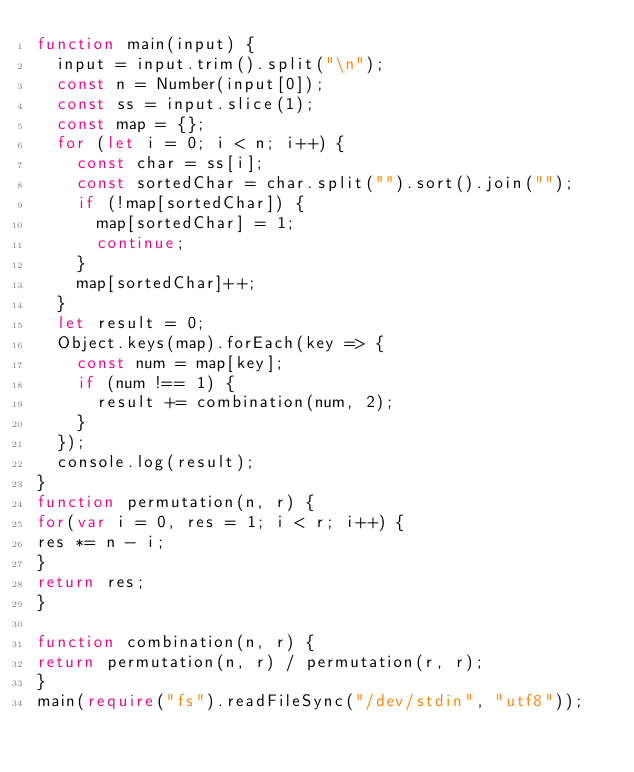<code> <loc_0><loc_0><loc_500><loc_500><_TypeScript_>function main(input) {
  input = input.trim().split("\n");
  const n = Number(input[0]);
  const ss = input.slice(1);
  const map = {};
  for (let i = 0; i < n; i++) {
    const char = ss[i];
    const sortedChar = char.split("").sort().join("");
    if (!map[sortedChar]) {
      map[sortedChar] = 1;
      continue;
    }
    map[sortedChar]++;
  }
  let result = 0;
  Object.keys(map).forEach(key => {
    const num = map[key];
    if (num !== 1) {
      result += combination(num, 2);
    }
  });
  console.log(result);
}
function permutation(n, r) {
for(var i = 0, res = 1; i < r; i++) {
res *= n - i;
}
return res;
}

function combination(n, r) {
return permutation(n, r) / permutation(r, r);
}
main(require("fs").readFileSync("/dev/stdin", "utf8"));</code> 